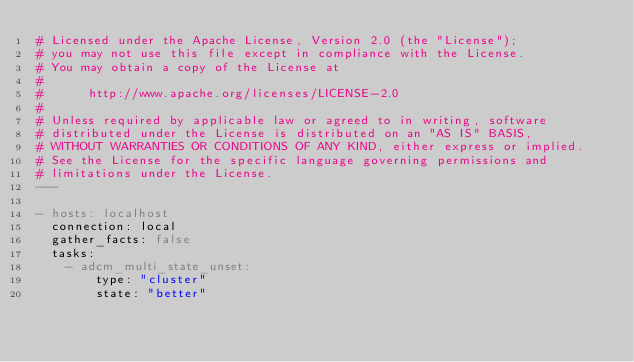Convert code to text. <code><loc_0><loc_0><loc_500><loc_500><_YAML_># Licensed under the Apache License, Version 2.0 (the "License");
# you may not use this file except in compliance with the License.
# You may obtain a copy of the License at
#
#      http://www.apache.org/licenses/LICENSE-2.0
#
# Unless required by applicable law or agreed to in writing, software
# distributed under the License is distributed on an "AS IS" BASIS,
# WITHOUT WARRANTIES OR CONDITIONS OF ANY KIND, either express or implied.
# See the License for the specific language governing permissions and
# limitations under the License.
---

- hosts: localhost
  connection: local
  gather_facts: false
  tasks:
    - adcm_multi_state_unset:
        type: "cluster"
        state: "better"
</code> 